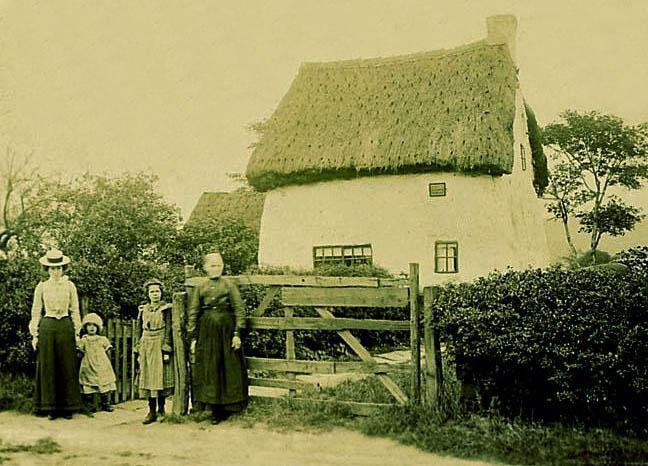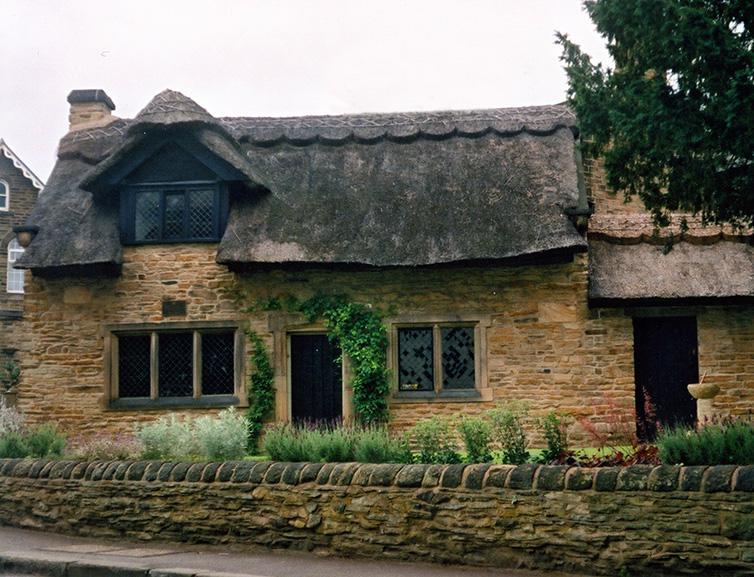The first image is the image on the left, the second image is the image on the right. Given the left and right images, does the statement "The left and right image contains the same number of full building with a single chimney on it." hold true? Answer yes or no. Yes. The first image is the image on the left, the second image is the image on the right. Evaluate the accuracy of this statement regarding the images: "The building in the left image has exactly one chimney.". Is it true? Answer yes or no. Yes. 